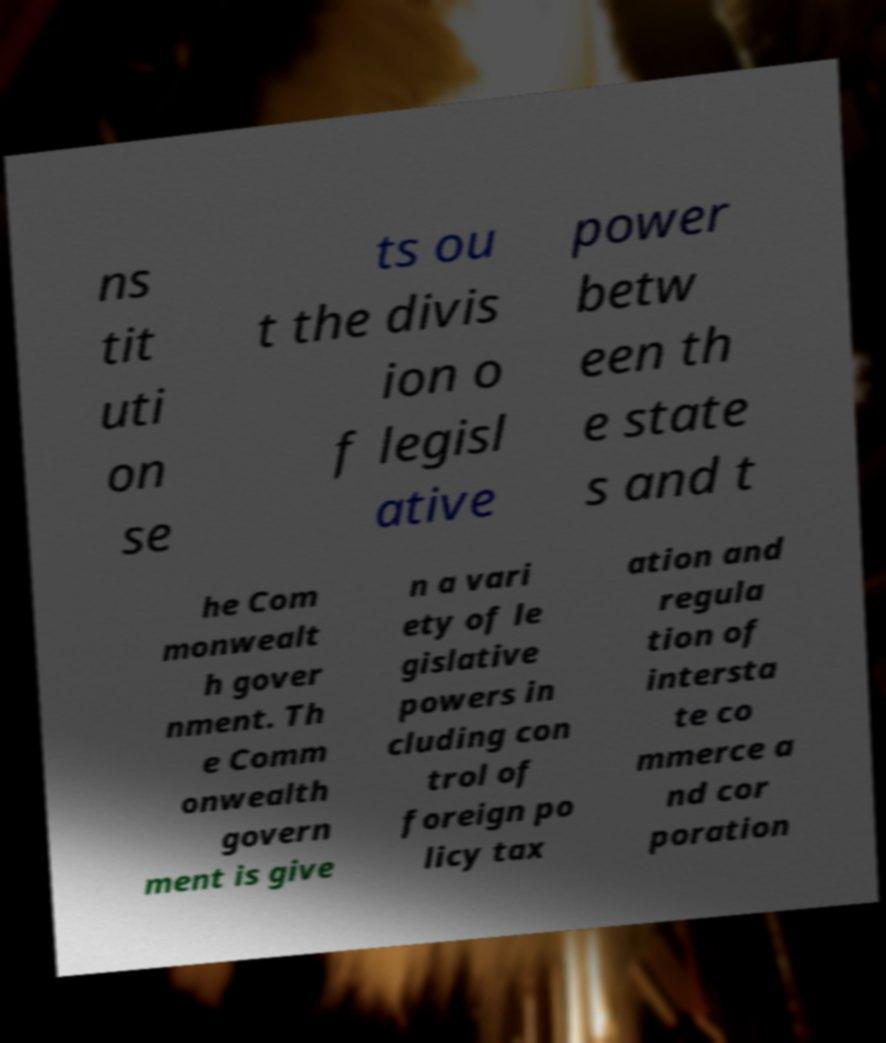For documentation purposes, I need the text within this image transcribed. Could you provide that? ns tit uti on se ts ou t the divis ion o f legisl ative power betw een th e state s and t he Com monwealt h gover nment. Th e Comm onwealth govern ment is give n a vari ety of le gislative powers in cluding con trol of foreign po licy tax ation and regula tion of intersta te co mmerce a nd cor poration 